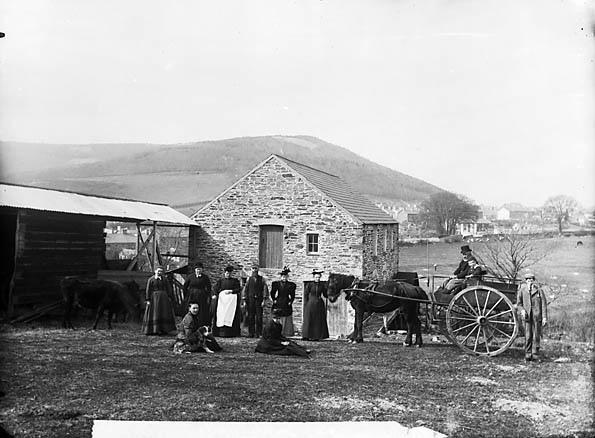What is pulling the cart?
Be succinct. Horse. How many horses are in this photograph?
Write a very short answer. 1. Is there a parade happening?
Give a very brief answer. No. How many people are in the picture?
Be succinct. 10. Are there wood beams up top?
Write a very short answer. Yes. How many people are in the carriage?
Give a very brief answer. 2. What material was used to make the house?
Concise answer only. Stone. How many people are seen?
Quick response, please. 10. Is the horse pulling a passenger trolley?
Be succinct. Yes. Is this a recent photo?
Answer briefly. No. What piece of clothing are the two people wearing that is similar in style and color?
Concise answer only. Dress. Is this a family picture taken long ago?
Concise answer only. Yes. What are these horses used for?
Quick response, please. Pull carriage. Is this downtown?
Quick response, please. No. How many people are there?
Keep it brief. 10. What is the roof of the structure made of?
Short answer required. Wood. How many people are in this picture?
Answer briefly. 11. 